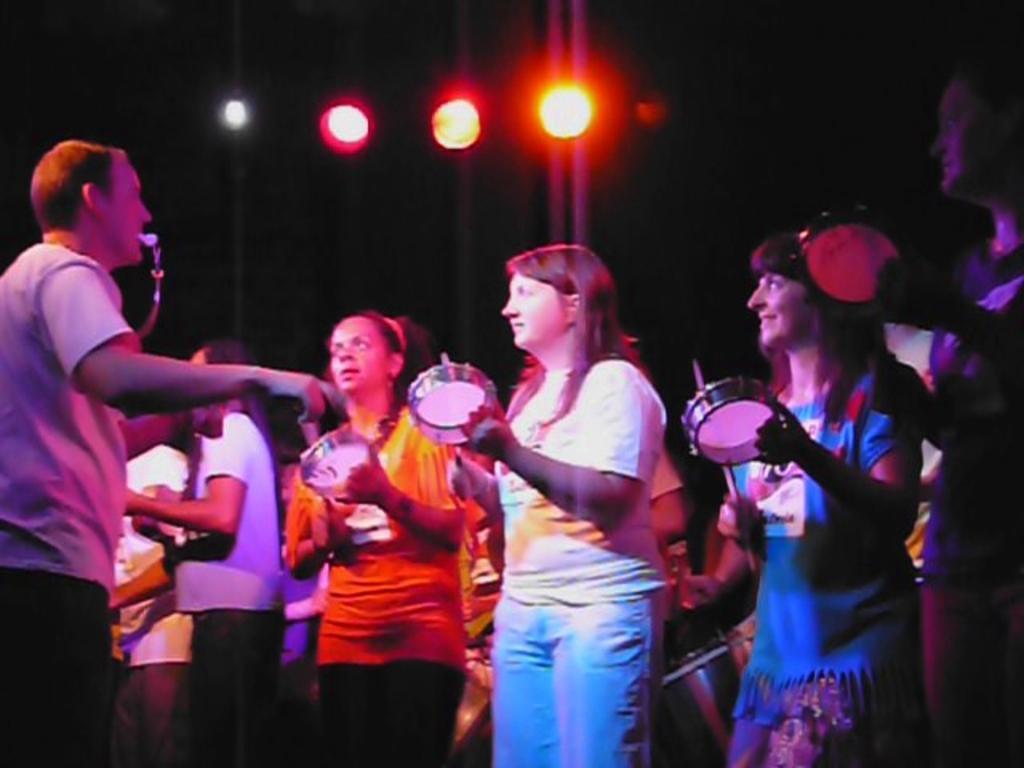How would you summarize this image in a sentence or two? In this image there are group of persons standing and holding musical instrument in their hands. In the background there are lights. 